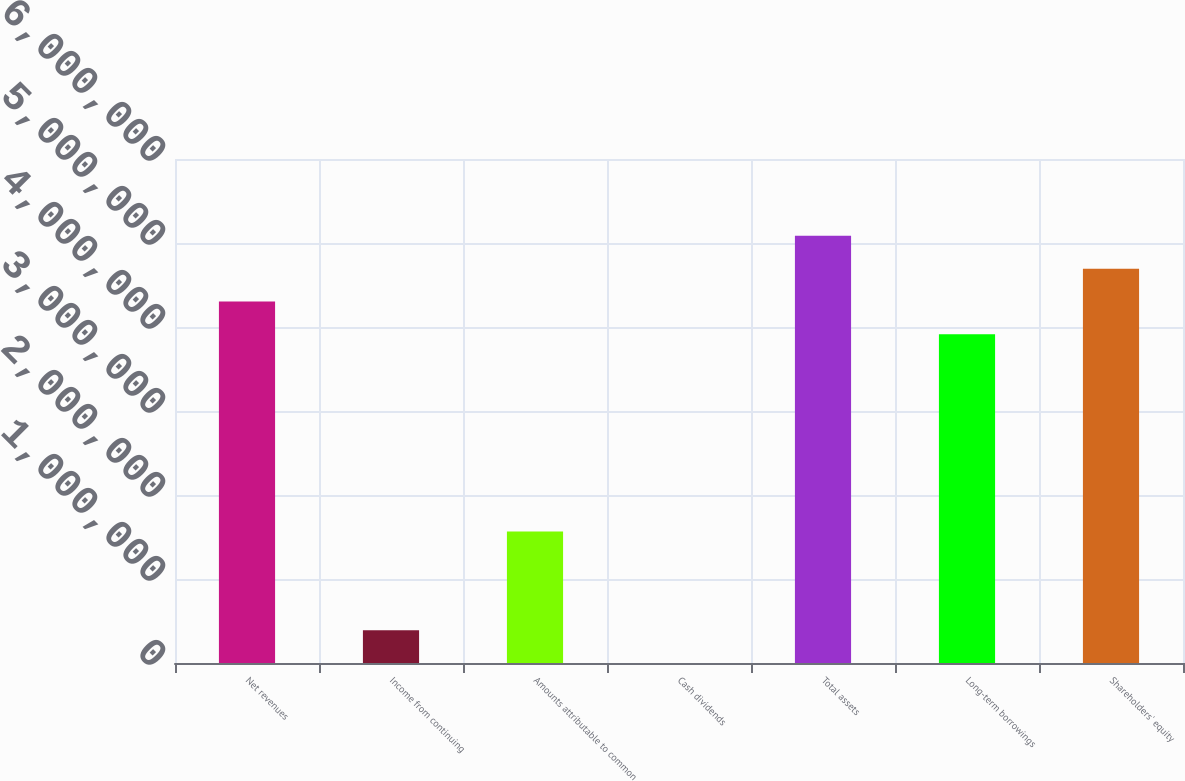Convert chart to OTSL. <chart><loc_0><loc_0><loc_500><loc_500><bar_chart><fcel>Net revenues<fcel>Income from continuing<fcel>Amounts attributable to common<fcel>Cash dividends<fcel>Total assets<fcel>Long-term borrowings<fcel>Shareholders' equity<nl><fcel>4.30367e+06<fcel>391244<fcel>1.56497e+06<fcel>1.36<fcel>5.08616e+06<fcel>3.91243e+06<fcel>4.69492e+06<nl></chart> 